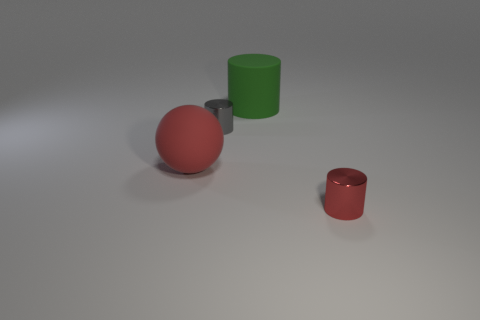Subtract all tiny cylinders. How many cylinders are left? 1 Add 1 large objects. How many objects exist? 5 Subtract all gray cylinders. How many cylinders are left? 2 Subtract 1 spheres. How many spheres are left? 0 Subtract all cylinders. How many objects are left? 1 Subtract all yellow spheres. Subtract all green cylinders. How many spheres are left? 1 Subtract all cyan balls. How many gray cylinders are left? 1 Subtract all tiny cyan rubber cubes. Subtract all small objects. How many objects are left? 2 Add 2 small gray metal cylinders. How many small gray metal cylinders are left? 3 Add 4 big rubber cylinders. How many big rubber cylinders exist? 5 